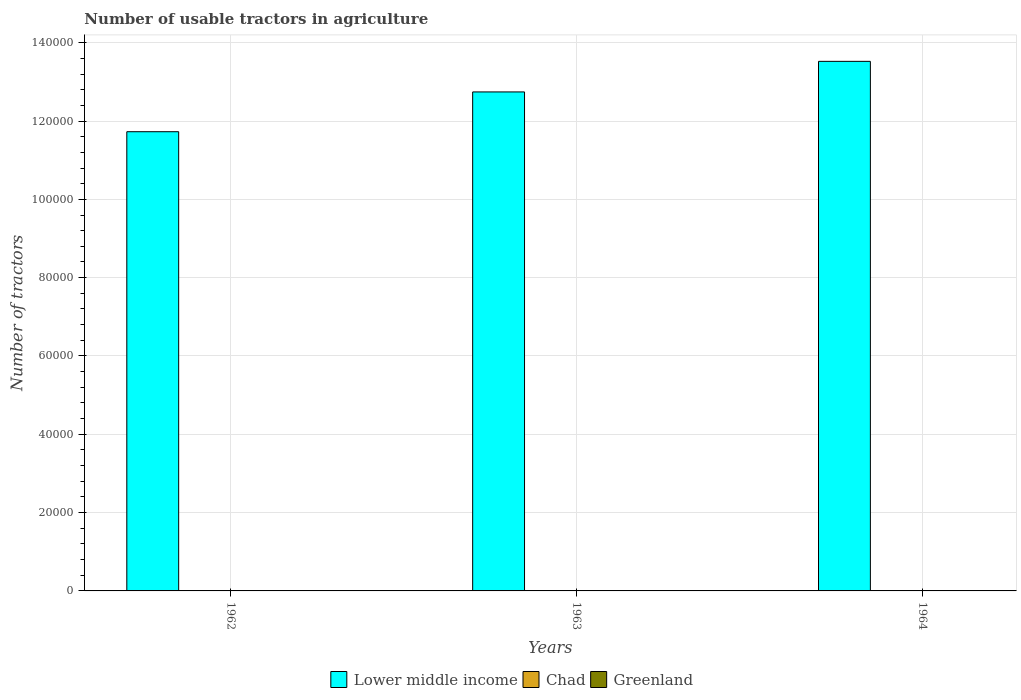Are the number of bars on each tick of the X-axis equal?
Your answer should be compact. Yes. How many bars are there on the 1st tick from the left?
Give a very brief answer. 3. What is the label of the 1st group of bars from the left?
Give a very brief answer. 1962. What is the number of usable tractors in agriculture in Lower middle income in 1962?
Your answer should be very brief. 1.17e+05. Across all years, what is the minimum number of usable tractors in agriculture in Lower middle income?
Give a very brief answer. 1.17e+05. In which year was the number of usable tractors in agriculture in Lower middle income maximum?
Provide a short and direct response. 1964. What is the difference between the number of usable tractors in agriculture in Lower middle income in 1962 and that in 1964?
Make the answer very short. -1.80e+04. What is the difference between the number of usable tractors in agriculture in Lower middle income in 1962 and the number of usable tractors in agriculture in Greenland in 1964?
Your response must be concise. 1.17e+05. What is the average number of usable tractors in agriculture in Chad per year?
Your answer should be very brief. 24.67. In the year 1964, what is the difference between the number of usable tractors in agriculture in Lower middle income and number of usable tractors in agriculture in Greenland?
Offer a very short reply. 1.35e+05. What is the ratio of the number of usable tractors in agriculture in Chad in 1962 to that in 1964?
Provide a short and direct response. 0.64. Is the difference between the number of usable tractors in agriculture in Lower middle income in 1962 and 1963 greater than the difference between the number of usable tractors in agriculture in Greenland in 1962 and 1963?
Ensure brevity in your answer.  No. What is the difference between the highest and the second highest number of usable tractors in agriculture in Greenland?
Give a very brief answer. 2. What is the difference between the highest and the lowest number of usable tractors in agriculture in Lower middle income?
Offer a very short reply. 1.80e+04. In how many years, is the number of usable tractors in agriculture in Chad greater than the average number of usable tractors in agriculture in Chad taken over all years?
Provide a succinct answer. 2. What does the 1st bar from the left in 1963 represents?
Keep it short and to the point. Lower middle income. What does the 3rd bar from the right in 1963 represents?
Keep it short and to the point. Lower middle income. Is it the case that in every year, the sum of the number of usable tractors in agriculture in Lower middle income and number of usable tractors in agriculture in Greenland is greater than the number of usable tractors in agriculture in Chad?
Make the answer very short. Yes. How many bars are there?
Provide a succinct answer. 9. How many years are there in the graph?
Provide a short and direct response. 3. What is the difference between two consecutive major ticks on the Y-axis?
Keep it short and to the point. 2.00e+04. Does the graph contain any zero values?
Keep it short and to the point. No. Does the graph contain grids?
Provide a succinct answer. Yes. How are the legend labels stacked?
Offer a terse response. Horizontal. What is the title of the graph?
Give a very brief answer. Number of usable tractors in agriculture. Does "Mozambique" appear as one of the legend labels in the graph?
Your response must be concise. No. What is the label or title of the X-axis?
Your answer should be very brief. Years. What is the label or title of the Y-axis?
Your answer should be compact. Number of tractors. What is the Number of tractors of Lower middle income in 1962?
Your response must be concise. 1.17e+05. What is the Number of tractors in Greenland in 1962?
Your answer should be compact. 40. What is the Number of tractors in Lower middle income in 1963?
Your answer should be compact. 1.27e+05. What is the Number of tractors of Chad in 1963?
Provide a succinct answer. 28. What is the Number of tractors in Greenland in 1963?
Keep it short and to the point. 42. What is the Number of tractors of Lower middle income in 1964?
Provide a short and direct response. 1.35e+05. What is the Number of tractors of Chad in 1964?
Offer a very short reply. 28. Across all years, what is the maximum Number of tractors of Lower middle income?
Keep it short and to the point. 1.35e+05. Across all years, what is the maximum Number of tractors of Chad?
Offer a terse response. 28. Across all years, what is the minimum Number of tractors of Lower middle income?
Your response must be concise. 1.17e+05. Across all years, what is the minimum Number of tractors of Greenland?
Keep it short and to the point. 40. What is the total Number of tractors of Lower middle income in the graph?
Provide a succinct answer. 3.80e+05. What is the total Number of tractors of Chad in the graph?
Offer a very short reply. 74. What is the total Number of tractors in Greenland in the graph?
Your response must be concise. 126. What is the difference between the Number of tractors in Lower middle income in 1962 and that in 1963?
Make the answer very short. -1.02e+04. What is the difference between the Number of tractors in Chad in 1962 and that in 1963?
Offer a very short reply. -10. What is the difference between the Number of tractors of Lower middle income in 1962 and that in 1964?
Offer a terse response. -1.80e+04. What is the difference between the Number of tractors in Lower middle income in 1963 and that in 1964?
Provide a short and direct response. -7810. What is the difference between the Number of tractors in Chad in 1963 and that in 1964?
Offer a terse response. 0. What is the difference between the Number of tractors in Greenland in 1963 and that in 1964?
Offer a very short reply. -2. What is the difference between the Number of tractors in Lower middle income in 1962 and the Number of tractors in Chad in 1963?
Ensure brevity in your answer.  1.17e+05. What is the difference between the Number of tractors in Lower middle income in 1962 and the Number of tractors in Greenland in 1963?
Keep it short and to the point. 1.17e+05. What is the difference between the Number of tractors in Chad in 1962 and the Number of tractors in Greenland in 1963?
Provide a short and direct response. -24. What is the difference between the Number of tractors of Lower middle income in 1962 and the Number of tractors of Chad in 1964?
Give a very brief answer. 1.17e+05. What is the difference between the Number of tractors of Lower middle income in 1962 and the Number of tractors of Greenland in 1964?
Your answer should be very brief. 1.17e+05. What is the difference between the Number of tractors of Lower middle income in 1963 and the Number of tractors of Chad in 1964?
Make the answer very short. 1.27e+05. What is the difference between the Number of tractors in Lower middle income in 1963 and the Number of tractors in Greenland in 1964?
Provide a succinct answer. 1.27e+05. What is the difference between the Number of tractors of Chad in 1963 and the Number of tractors of Greenland in 1964?
Make the answer very short. -16. What is the average Number of tractors of Lower middle income per year?
Offer a terse response. 1.27e+05. What is the average Number of tractors of Chad per year?
Ensure brevity in your answer.  24.67. In the year 1962, what is the difference between the Number of tractors of Lower middle income and Number of tractors of Chad?
Keep it short and to the point. 1.17e+05. In the year 1962, what is the difference between the Number of tractors of Lower middle income and Number of tractors of Greenland?
Your answer should be very brief. 1.17e+05. In the year 1963, what is the difference between the Number of tractors in Lower middle income and Number of tractors in Chad?
Provide a short and direct response. 1.27e+05. In the year 1963, what is the difference between the Number of tractors in Lower middle income and Number of tractors in Greenland?
Your answer should be compact. 1.27e+05. In the year 1963, what is the difference between the Number of tractors of Chad and Number of tractors of Greenland?
Provide a short and direct response. -14. In the year 1964, what is the difference between the Number of tractors in Lower middle income and Number of tractors in Chad?
Make the answer very short. 1.35e+05. In the year 1964, what is the difference between the Number of tractors of Lower middle income and Number of tractors of Greenland?
Offer a very short reply. 1.35e+05. In the year 1964, what is the difference between the Number of tractors of Chad and Number of tractors of Greenland?
Offer a terse response. -16. What is the ratio of the Number of tractors in Lower middle income in 1962 to that in 1963?
Offer a terse response. 0.92. What is the ratio of the Number of tractors in Chad in 1962 to that in 1963?
Your response must be concise. 0.64. What is the ratio of the Number of tractors in Lower middle income in 1962 to that in 1964?
Ensure brevity in your answer.  0.87. What is the ratio of the Number of tractors of Chad in 1962 to that in 1964?
Keep it short and to the point. 0.64. What is the ratio of the Number of tractors in Greenland in 1962 to that in 1964?
Give a very brief answer. 0.91. What is the ratio of the Number of tractors of Lower middle income in 1963 to that in 1964?
Keep it short and to the point. 0.94. What is the ratio of the Number of tractors in Chad in 1963 to that in 1964?
Ensure brevity in your answer.  1. What is the ratio of the Number of tractors in Greenland in 1963 to that in 1964?
Offer a very short reply. 0.95. What is the difference between the highest and the second highest Number of tractors in Lower middle income?
Ensure brevity in your answer.  7810. What is the difference between the highest and the lowest Number of tractors in Lower middle income?
Make the answer very short. 1.80e+04. What is the difference between the highest and the lowest Number of tractors in Chad?
Provide a short and direct response. 10. What is the difference between the highest and the lowest Number of tractors in Greenland?
Keep it short and to the point. 4. 